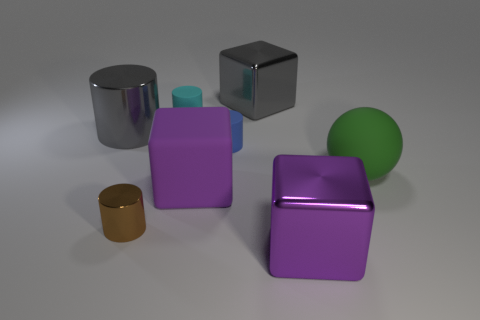Is there any other thing that is the same shape as the big green matte thing?
Provide a short and direct response. No. There is a cylinder that is the same size as the green rubber thing; what color is it?
Your answer should be compact. Gray. How many objects are either small brown metallic cubes or big objects?
Your response must be concise. 5. What size is the gray thing to the right of the big gray metallic thing left of the cyan rubber thing to the right of the brown shiny thing?
Give a very brief answer. Large. What number of big things have the same color as the large metal cylinder?
Offer a very short reply. 1. How many tiny cyan objects have the same material as the cyan cylinder?
Your answer should be very brief. 0. How many things are either small brown cylinders or tiny cylinders that are to the right of the purple rubber cube?
Offer a very short reply. 2. There is a small matte cylinder in front of the big gray thing that is on the left side of the tiny rubber object that is to the right of the cyan cylinder; what color is it?
Your answer should be compact. Blue. How big is the gray object that is right of the large purple rubber cube?
Your answer should be compact. Large. What number of large objects are yellow metallic objects or matte things?
Keep it short and to the point. 2. 